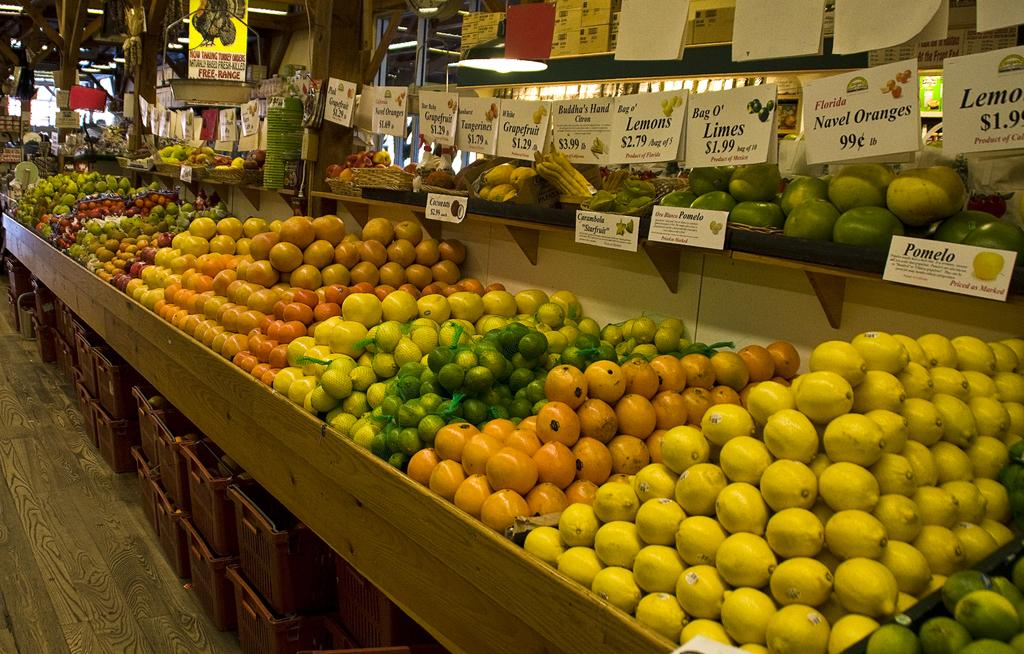What type of objects are on the wooden shelf in the image? There are many fruits on the wooden shelf in the image. What else can be seen in the image besides the fruits? There are baskets in the image. How can you determine the price of the fruits in the image? Price tags are present in the image. What type of lighting is visible in the image? Ceiling lights are visible in the image. What emotion does the fruit feel when it is being sold at a higher price than expected? Fruits do not have emotions, so it is not possible to determine how they feel when being sold at a higher price than expected. 